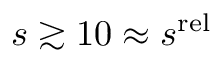Convert formula to latex. <formula><loc_0><loc_0><loc_500><loc_500>s \gtrsim 1 0 \approx s ^ { r e l }</formula> 